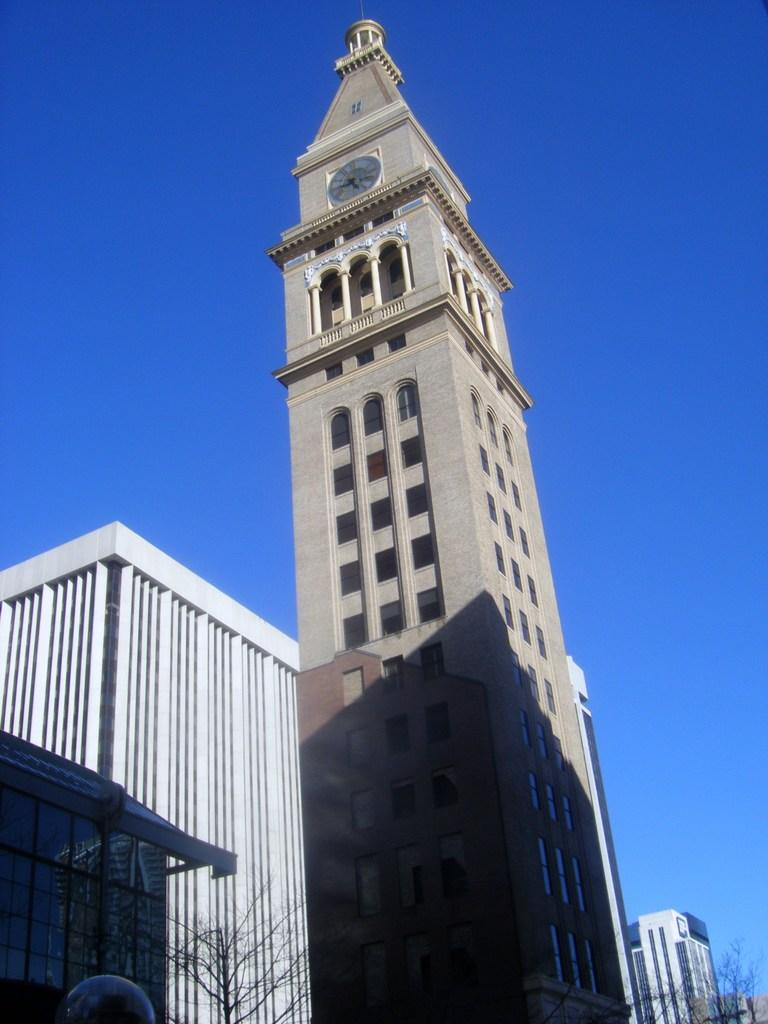What type of natural element is present in the image? There is a tree in the image. What type of man-made structures can be seen in the image? There are buildings and a clock tower in the image. What is the purpose of the clock tower in the image? The clock tower is likely used for telling time. What can be seen in the background of the image? The sky is visible behind the clock tower. What type of toothbrush is hanging from the tree in the image? There is no toothbrush present in the image. What kind of adjustment is being made to the clock tower in the image? There is no adjustment being made to the clock tower in the image; it appears to be stationary. 